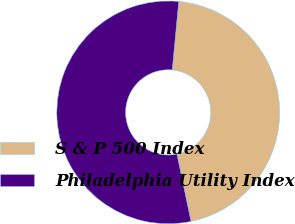Convert chart. <chart><loc_0><loc_0><loc_500><loc_500><pie_chart><fcel>S & P 500 Index<fcel>Philadelphia Utility Index<nl><fcel>45.21%<fcel>54.79%<nl></chart> 